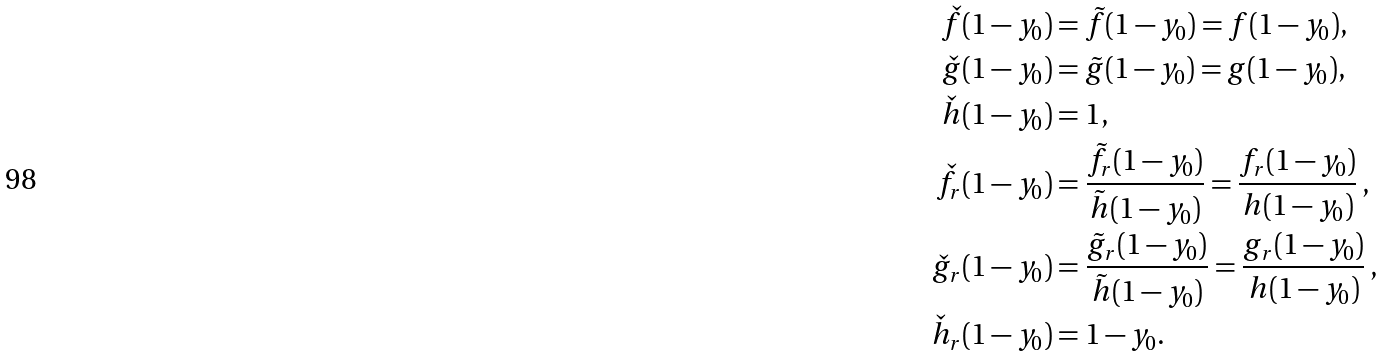<formula> <loc_0><loc_0><loc_500><loc_500>\check { f } ( 1 - y _ { 0 } ) & = \tilde { f } ( 1 - y _ { 0 } ) = f ( 1 - y _ { 0 } ) , \\ \check { g } ( 1 - y _ { 0 } ) & = \tilde { g } ( 1 - y _ { 0 } ) = g ( 1 - y _ { 0 } ) , \\ \check { h } ( 1 - y _ { 0 } ) & = 1 , \\ \check { f } _ { r } ( 1 - y _ { 0 } ) & = \frac { \tilde { f } _ { r } ( 1 - y _ { 0 } ) } { \tilde { h } ( 1 - y _ { 0 } ) } = \frac { f _ { r } ( 1 - y _ { 0 } ) } { h ( 1 - y _ { 0 } ) } \, , \\ \check { g } _ { r } ( 1 - y _ { 0 } ) & = \frac { \tilde { g } _ { r } ( 1 - y _ { 0 } ) } { \tilde { h } ( 1 - y _ { 0 } ) } = \frac { g _ { r } ( 1 - y _ { 0 } ) } { h ( 1 - y _ { 0 } ) } \, , \\ \check { h } _ { r } ( 1 - y _ { 0 } ) & = 1 - y _ { 0 } .</formula> 